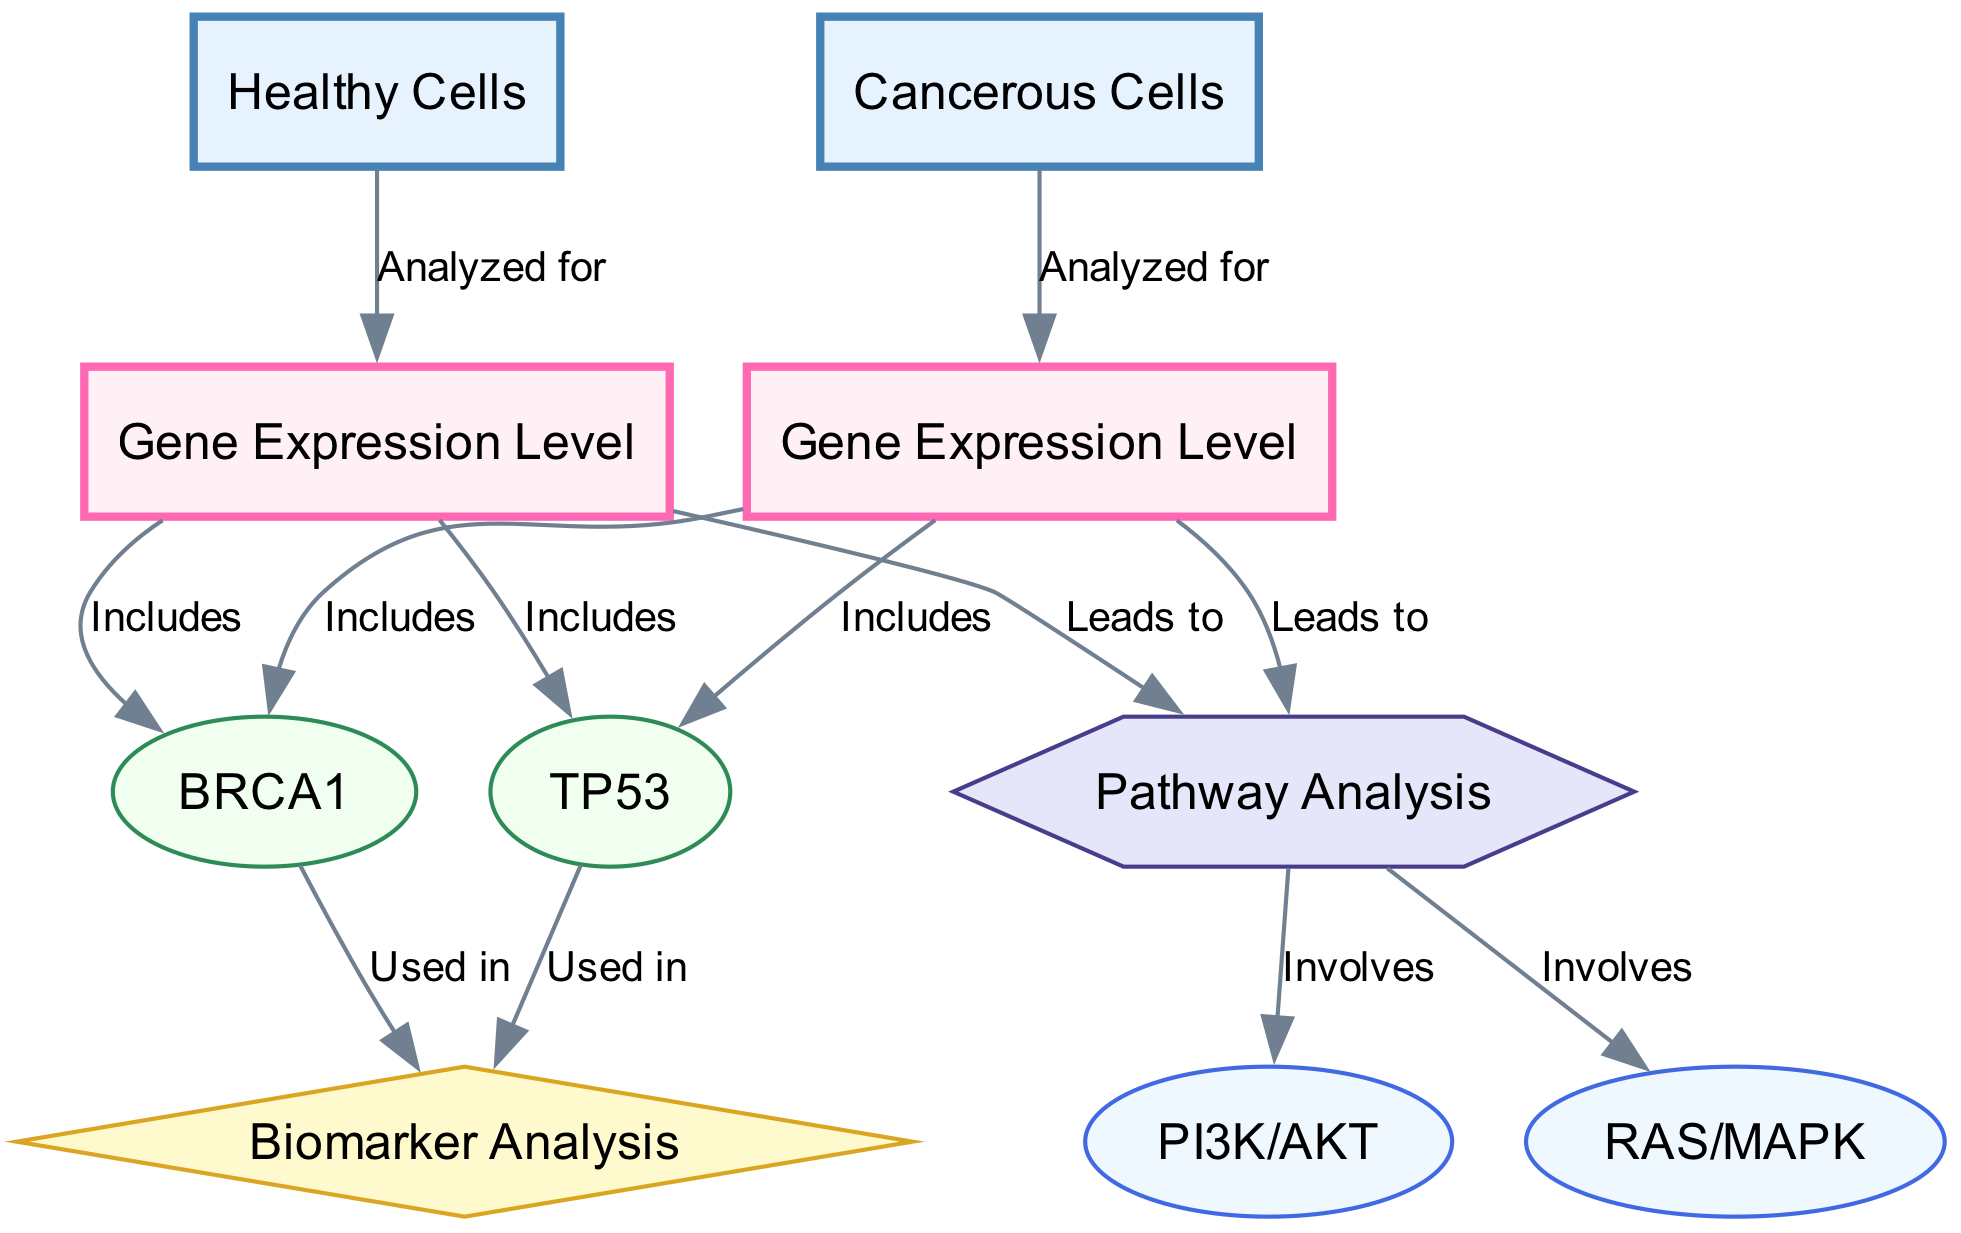What are the two types of cells analyzed in the diagram? The diagram represents two types of cells: Healthy Cells and Cancerous Cells. This can be seen at the start of the flow where these cell types are defined as the basis for gene expression analysis.
Answer: Healthy Cells, Cancerous Cells How many genes are included in the gene expression levels for healthy and cancerous cells? Both healthy and cancerous gene expression levels include two genes: BRCA1 and TP53. This is confirmed by the edges emanating from both gene expression levels to these specific genes.
Answer: 2 What is the analytical process for gene expression in healthy cells? The flow for healthy cells shows that the gene expression level leads to a pathway analysis which involves pathways like PI3K/AKT and RAS/MAPK. Thus, the scheme for healthy cells involves analyzing gene expression followed by pathway analysis.
Answer: Analyzing gene expression followed by pathway analysis What is the relationship between TP53 and biomarker analysis? The diagram indicates that TP53 is used in biomarker analysis, as evidenced by the edge connecting TP53 to the biomarker analysis node. This shows that TP53 has a functional role in biomarkers concerning cancerous and healthy cells.
Answer: Used in Which pathways are involved in the pathway analysis from both cell types? The pathway analysis connects to two pathways: PI3K/AKT and RAS/MAPK, indicating that these pathways are relevant for both healthy and cancerous cells' gene expression levels. This is clearly shown in the connections extending from pathway analysis.
Answer: PI3K/AKT, RAS/MAPK How do gene expression levels for cancerous cells lead to further analysis? The cancerous cells' gene expression levels include BRCA1 and TP53 and lead to the same pathway analysis as the healthy cells. This indicates that the investigative process for gene expressions parallels for both cell types, hence necessitating a similar analytical structure.
Answer: Leads to pathway analysis 